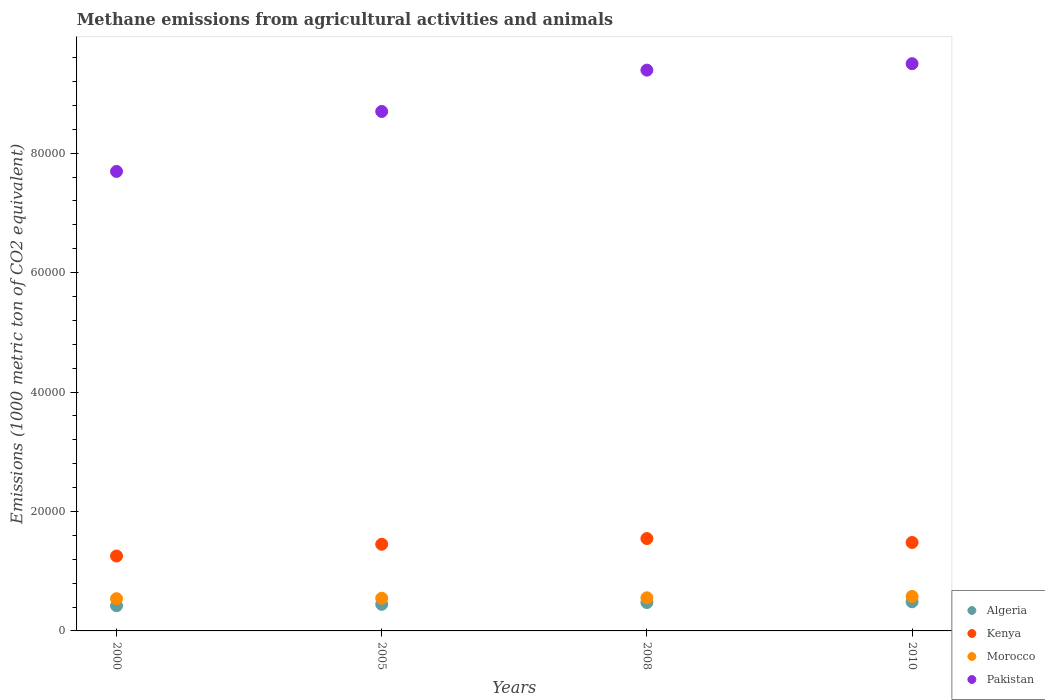How many different coloured dotlines are there?
Keep it short and to the point. 4. Is the number of dotlines equal to the number of legend labels?
Provide a short and direct response. Yes. What is the amount of methane emitted in Morocco in 2008?
Offer a very short reply. 5546.4. Across all years, what is the maximum amount of methane emitted in Algeria?
Your answer should be very brief. 4872.2. Across all years, what is the minimum amount of methane emitted in Kenya?
Keep it short and to the point. 1.25e+04. In which year was the amount of methane emitted in Algeria maximum?
Make the answer very short. 2010. In which year was the amount of methane emitted in Morocco minimum?
Your response must be concise. 2000. What is the total amount of methane emitted in Kenya in the graph?
Make the answer very short. 5.73e+04. What is the difference between the amount of methane emitted in Pakistan in 2000 and that in 2008?
Make the answer very short. -1.70e+04. What is the difference between the amount of methane emitted in Algeria in 2005 and the amount of methane emitted in Morocco in 2010?
Your answer should be very brief. -1327. What is the average amount of methane emitted in Pakistan per year?
Keep it short and to the point. 8.82e+04. In the year 2008, what is the difference between the amount of methane emitted in Kenya and amount of methane emitted in Pakistan?
Ensure brevity in your answer.  -7.84e+04. What is the ratio of the amount of methane emitted in Kenya in 2000 to that in 2010?
Offer a very short reply. 0.85. Is the amount of methane emitted in Algeria in 2000 less than that in 2010?
Keep it short and to the point. Yes. Is the difference between the amount of methane emitted in Kenya in 2000 and 2005 greater than the difference between the amount of methane emitted in Pakistan in 2000 and 2005?
Keep it short and to the point. Yes. What is the difference between the highest and the second highest amount of methane emitted in Morocco?
Provide a short and direct response. 232.7. What is the difference between the highest and the lowest amount of methane emitted in Kenya?
Your answer should be compact. 2922.2. Is it the case that in every year, the sum of the amount of methane emitted in Morocco and amount of methane emitted in Algeria  is greater than the amount of methane emitted in Pakistan?
Provide a short and direct response. No. Is the amount of methane emitted in Morocco strictly greater than the amount of methane emitted in Pakistan over the years?
Make the answer very short. No. How many years are there in the graph?
Ensure brevity in your answer.  4. What is the difference between two consecutive major ticks on the Y-axis?
Your answer should be very brief. 2.00e+04. Does the graph contain any zero values?
Your response must be concise. No. Does the graph contain grids?
Offer a terse response. No. Where does the legend appear in the graph?
Offer a very short reply. Bottom right. What is the title of the graph?
Make the answer very short. Methane emissions from agricultural activities and animals. Does "Guatemala" appear as one of the legend labels in the graph?
Keep it short and to the point. No. What is the label or title of the X-axis?
Your response must be concise. Years. What is the label or title of the Y-axis?
Offer a very short reply. Emissions (1000 metric ton of CO2 equivalent). What is the Emissions (1000 metric ton of CO2 equivalent) of Algeria in 2000?
Give a very brief answer. 4216.3. What is the Emissions (1000 metric ton of CO2 equivalent) of Kenya in 2000?
Offer a terse response. 1.25e+04. What is the Emissions (1000 metric ton of CO2 equivalent) in Morocco in 2000?
Keep it short and to the point. 5400.3. What is the Emissions (1000 metric ton of CO2 equivalent) in Pakistan in 2000?
Offer a terse response. 7.69e+04. What is the Emissions (1000 metric ton of CO2 equivalent) of Algeria in 2005?
Keep it short and to the point. 4452.1. What is the Emissions (1000 metric ton of CO2 equivalent) of Kenya in 2005?
Ensure brevity in your answer.  1.45e+04. What is the Emissions (1000 metric ton of CO2 equivalent) of Morocco in 2005?
Keep it short and to the point. 5471.4. What is the Emissions (1000 metric ton of CO2 equivalent) of Pakistan in 2005?
Your response must be concise. 8.70e+04. What is the Emissions (1000 metric ton of CO2 equivalent) of Algeria in 2008?
Provide a short and direct response. 4754.7. What is the Emissions (1000 metric ton of CO2 equivalent) in Kenya in 2008?
Your response must be concise. 1.55e+04. What is the Emissions (1000 metric ton of CO2 equivalent) in Morocco in 2008?
Make the answer very short. 5546.4. What is the Emissions (1000 metric ton of CO2 equivalent) in Pakistan in 2008?
Offer a terse response. 9.39e+04. What is the Emissions (1000 metric ton of CO2 equivalent) in Algeria in 2010?
Your answer should be compact. 4872.2. What is the Emissions (1000 metric ton of CO2 equivalent) in Kenya in 2010?
Give a very brief answer. 1.48e+04. What is the Emissions (1000 metric ton of CO2 equivalent) of Morocco in 2010?
Provide a short and direct response. 5779.1. What is the Emissions (1000 metric ton of CO2 equivalent) in Pakistan in 2010?
Provide a succinct answer. 9.50e+04. Across all years, what is the maximum Emissions (1000 metric ton of CO2 equivalent) in Algeria?
Offer a very short reply. 4872.2. Across all years, what is the maximum Emissions (1000 metric ton of CO2 equivalent) of Kenya?
Offer a very short reply. 1.55e+04. Across all years, what is the maximum Emissions (1000 metric ton of CO2 equivalent) of Morocco?
Offer a terse response. 5779.1. Across all years, what is the maximum Emissions (1000 metric ton of CO2 equivalent) in Pakistan?
Keep it short and to the point. 9.50e+04. Across all years, what is the minimum Emissions (1000 metric ton of CO2 equivalent) in Algeria?
Provide a succinct answer. 4216.3. Across all years, what is the minimum Emissions (1000 metric ton of CO2 equivalent) of Kenya?
Keep it short and to the point. 1.25e+04. Across all years, what is the minimum Emissions (1000 metric ton of CO2 equivalent) in Morocco?
Keep it short and to the point. 5400.3. Across all years, what is the minimum Emissions (1000 metric ton of CO2 equivalent) of Pakistan?
Your answer should be compact. 7.69e+04. What is the total Emissions (1000 metric ton of CO2 equivalent) in Algeria in the graph?
Ensure brevity in your answer.  1.83e+04. What is the total Emissions (1000 metric ton of CO2 equivalent) of Kenya in the graph?
Keep it short and to the point. 5.73e+04. What is the total Emissions (1000 metric ton of CO2 equivalent) in Morocco in the graph?
Your answer should be compact. 2.22e+04. What is the total Emissions (1000 metric ton of CO2 equivalent) in Pakistan in the graph?
Give a very brief answer. 3.53e+05. What is the difference between the Emissions (1000 metric ton of CO2 equivalent) of Algeria in 2000 and that in 2005?
Your answer should be compact. -235.8. What is the difference between the Emissions (1000 metric ton of CO2 equivalent) of Kenya in 2000 and that in 2005?
Your answer should be very brief. -1969.1. What is the difference between the Emissions (1000 metric ton of CO2 equivalent) of Morocco in 2000 and that in 2005?
Your response must be concise. -71.1. What is the difference between the Emissions (1000 metric ton of CO2 equivalent) in Pakistan in 2000 and that in 2005?
Your response must be concise. -1.00e+04. What is the difference between the Emissions (1000 metric ton of CO2 equivalent) of Algeria in 2000 and that in 2008?
Make the answer very short. -538.4. What is the difference between the Emissions (1000 metric ton of CO2 equivalent) in Kenya in 2000 and that in 2008?
Provide a short and direct response. -2922.2. What is the difference between the Emissions (1000 metric ton of CO2 equivalent) of Morocco in 2000 and that in 2008?
Your answer should be very brief. -146.1. What is the difference between the Emissions (1000 metric ton of CO2 equivalent) in Pakistan in 2000 and that in 2008?
Ensure brevity in your answer.  -1.70e+04. What is the difference between the Emissions (1000 metric ton of CO2 equivalent) of Algeria in 2000 and that in 2010?
Ensure brevity in your answer.  -655.9. What is the difference between the Emissions (1000 metric ton of CO2 equivalent) in Kenya in 2000 and that in 2010?
Your answer should be very brief. -2265.8. What is the difference between the Emissions (1000 metric ton of CO2 equivalent) in Morocco in 2000 and that in 2010?
Keep it short and to the point. -378.8. What is the difference between the Emissions (1000 metric ton of CO2 equivalent) in Pakistan in 2000 and that in 2010?
Give a very brief answer. -1.80e+04. What is the difference between the Emissions (1000 metric ton of CO2 equivalent) of Algeria in 2005 and that in 2008?
Give a very brief answer. -302.6. What is the difference between the Emissions (1000 metric ton of CO2 equivalent) in Kenya in 2005 and that in 2008?
Offer a very short reply. -953.1. What is the difference between the Emissions (1000 metric ton of CO2 equivalent) in Morocco in 2005 and that in 2008?
Provide a succinct answer. -75. What is the difference between the Emissions (1000 metric ton of CO2 equivalent) in Pakistan in 2005 and that in 2008?
Keep it short and to the point. -6920.4. What is the difference between the Emissions (1000 metric ton of CO2 equivalent) in Algeria in 2005 and that in 2010?
Make the answer very short. -420.1. What is the difference between the Emissions (1000 metric ton of CO2 equivalent) of Kenya in 2005 and that in 2010?
Your answer should be compact. -296.7. What is the difference between the Emissions (1000 metric ton of CO2 equivalent) in Morocco in 2005 and that in 2010?
Ensure brevity in your answer.  -307.7. What is the difference between the Emissions (1000 metric ton of CO2 equivalent) in Pakistan in 2005 and that in 2010?
Your response must be concise. -8002.4. What is the difference between the Emissions (1000 metric ton of CO2 equivalent) in Algeria in 2008 and that in 2010?
Make the answer very short. -117.5. What is the difference between the Emissions (1000 metric ton of CO2 equivalent) of Kenya in 2008 and that in 2010?
Offer a very short reply. 656.4. What is the difference between the Emissions (1000 metric ton of CO2 equivalent) of Morocco in 2008 and that in 2010?
Your answer should be compact. -232.7. What is the difference between the Emissions (1000 metric ton of CO2 equivalent) in Pakistan in 2008 and that in 2010?
Your answer should be very brief. -1082. What is the difference between the Emissions (1000 metric ton of CO2 equivalent) of Algeria in 2000 and the Emissions (1000 metric ton of CO2 equivalent) of Kenya in 2005?
Ensure brevity in your answer.  -1.03e+04. What is the difference between the Emissions (1000 metric ton of CO2 equivalent) in Algeria in 2000 and the Emissions (1000 metric ton of CO2 equivalent) in Morocco in 2005?
Your response must be concise. -1255.1. What is the difference between the Emissions (1000 metric ton of CO2 equivalent) in Algeria in 2000 and the Emissions (1000 metric ton of CO2 equivalent) in Pakistan in 2005?
Your response must be concise. -8.28e+04. What is the difference between the Emissions (1000 metric ton of CO2 equivalent) of Kenya in 2000 and the Emissions (1000 metric ton of CO2 equivalent) of Morocco in 2005?
Give a very brief answer. 7072.2. What is the difference between the Emissions (1000 metric ton of CO2 equivalent) in Kenya in 2000 and the Emissions (1000 metric ton of CO2 equivalent) in Pakistan in 2005?
Give a very brief answer. -7.44e+04. What is the difference between the Emissions (1000 metric ton of CO2 equivalent) of Morocco in 2000 and the Emissions (1000 metric ton of CO2 equivalent) of Pakistan in 2005?
Ensure brevity in your answer.  -8.16e+04. What is the difference between the Emissions (1000 metric ton of CO2 equivalent) of Algeria in 2000 and the Emissions (1000 metric ton of CO2 equivalent) of Kenya in 2008?
Keep it short and to the point. -1.12e+04. What is the difference between the Emissions (1000 metric ton of CO2 equivalent) of Algeria in 2000 and the Emissions (1000 metric ton of CO2 equivalent) of Morocco in 2008?
Provide a short and direct response. -1330.1. What is the difference between the Emissions (1000 metric ton of CO2 equivalent) of Algeria in 2000 and the Emissions (1000 metric ton of CO2 equivalent) of Pakistan in 2008?
Your answer should be very brief. -8.97e+04. What is the difference between the Emissions (1000 metric ton of CO2 equivalent) of Kenya in 2000 and the Emissions (1000 metric ton of CO2 equivalent) of Morocco in 2008?
Your answer should be compact. 6997.2. What is the difference between the Emissions (1000 metric ton of CO2 equivalent) in Kenya in 2000 and the Emissions (1000 metric ton of CO2 equivalent) in Pakistan in 2008?
Your response must be concise. -8.14e+04. What is the difference between the Emissions (1000 metric ton of CO2 equivalent) of Morocco in 2000 and the Emissions (1000 metric ton of CO2 equivalent) of Pakistan in 2008?
Your answer should be compact. -8.85e+04. What is the difference between the Emissions (1000 metric ton of CO2 equivalent) of Algeria in 2000 and the Emissions (1000 metric ton of CO2 equivalent) of Kenya in 2010?
Your response must be concise. -1.06e+04. What is the difference between the Emissions (1000 metric ton of CO2 equivalent) of Algeria in 2000 and the Emissions (1000 metric ton of CO2 equivalent) of Morocco in 2010?
Provide a succinct answer. -1562.8. What is the difference between the Emissions (1000 metric ton of CO2 equivalent) in Algeria in 2000 and the Emissions (1000 metric ton of CO2 equivalent) in Pakistan in 2010?
Your answer should be very brief. -9.08e+04. What is the difference between the Emissions (1000 metric ton of CO2 equivalent) of Kenya in 2000 and the Emissions (1000 metric ton of CO2 equivalent) of Morocco in 2010?
Ensure brevity in your answer.  6764.5. What is the difference between the Emissions (1000 metric ton of CO2 equivalent) of Kenya in 2000 and the Emissions (1000 metric ton of CO2 equivalent) of Pakistan in 2010?
Offer a terse response. -8.24e+04. What is the difference between the Emissions (1000 metric ton of CO2 equivalent) in Morocco in 2000 and the Emissions (1000 metric ton of CO2 equivalent) in Pakistan in 2010?
Provide a short and direct response. -8.96e+04. What is the difference between the Emissions (1000 metric ton of CO2 equivalent) of Algeria in 2005 and the Emissions (1000 metric ton of CO2 equivalent) of Kenya in 2008?
Provide a short and direct response. -1.10e+04. What is the difference between the Emissions (1000 metric ton of CO2 equivalent) of Algeria in 2005 and the Emissions (1000 metric ton of CO2 equivalent) of Morocco in 2008?
Offer a terse response. -1094.3. What is the difference between the Emissions (1000 metric ton of CO2 equivalent) of Algeria in 2005 and the Emissions (1000 metric ton of CO2 equivalent) of Pakistan in 2008?
Provide a succinct answer. -8.95e+04. What is the difference between the Emissions (1000 metric ton of CO2 equivalent) of Kenya in 2005 and the Emissions (1000 metric ton of CO2 equivalent) of Morocco in 2008?
Provide a succinct answer. 8966.3. What is the difference between the Emissions (1000 metric ton of CO2 equivalent) in Kenya in 2005 and the Emissions (1000 metric ton of CO2 equivalent) in Pakistan in 2008?
Give a very brief answer. -7.94e+04. What is the difference between the Emissions (1000 metric ton of CO2 equivalent) of Morocco in 2005 and the Emissions (1000 metric ton of CO2 equivalent) of Pakistan in 2008?
Your response must be concise. -8.84e+04. What is the difference between the Emissions (1000 metric ton of CO2 equivalent) of Algeria in 2005 and the Emissions (1000 metric ton of CO2 equivalent) of Kenya in 2010?
Ensure brevity in your answer.  -1.04e+04. What is the difference between the Emissions (1000 metric ton of CO2 equivalent) of Algeria in 2005 and the Emissions (1000 metric ton of CO2 equivalent) of Morocco in 2010?
Your answer should be very brief. -1327. What is the difference between the Emissions (1000 metric ton of CO2 equivalent) of Algeria in 2005 and the Emissions (1000 metric ton of CO2 equivalent) of Pakistan in 2010?
Offer a terse response. -9.05e+04. What is the difference between the Emissions (1000 metric ton of CO2 equivalent) in Kenya in 2005 and the Emissions (1000 metric ton of CO2 equivalent) in Morocco in 2010?
Your answer should be very brief. 8733.6. What is the difference between the Emissions (1000 metric ton of CO2 equivalent) in Kenya in 2005 and the Emissions (1000 metric ton of CO2 equivalent) in Pakistan in 2010?
Make the answer very short. -8.05e+04. What is the difference between the Emissions (1000 metric ton of CO2 equivalent) of Morocco in 2005 and the Emissions (1000 metric ton of CO2 equivalent) of Pakistan in 2010?
Offer a terse response. -8.95e+04. What is the difference between the Emissions (1000 metric ton of CO2 equivalent) in Algeria in 2008 and the Emissions (1000 metric ton of CO2 equivalent) in Kenya in 2010?
Keep it short and to the point. -1.01e+04. What is the difference between the Emissions (1000 metric ton of CO2 equivalent) of Algeria in 2008 and the Emissions (1000 metric ton of CO2 equivalent) of Morocco in 2010?
Your answer should be compact. -1024.4. What is the difference between the Emissions (1000 metric ton of CO2 equivalent) of Algeria in 2008 and the Emissions (1000 metric ton of CO2 equivalent) of Pakistan in 2010?
Offer a terse response. -9.02e+04. What is the difference between the Emissions (1000 metric ton of CO2 equivalent) in Kenya in 2008 and the Emissions (1000 metric ton of CO2 equivalent) in Morocco in 2010?
Your response must be concise. 9686.7. What is the difference between the Emissions (1000 metric ton of CO2 equivalent) of Kenya in 2008 and the Emissions (1000 metric ton of CO2 equivalent) of Pakistan in 2010?
Your answer should be compact. -7.95e+04. What is the difference between the Emissions (1000 metric ton of CO2 equivalent) of Morocco in 2008 and the Emissions (1000 metric ton of CO2 equivalent) of Pakistan in 2010?
Offer a very short reply. -8.94e+04. What is the average Emissions (1000 metric ton of CO2 equivalent) of Algeria per year?
Provide a short and direct response. 4573.82. What is the average Emissions (1000 metric ton of CO2 equivalent) in Kenya per year?
Your answer should be very brief. 1.43e+04. What is the average Emissions (1000 metric ton of CO2 equivalent) of Morocco per year?
Give a very brief answer. 5549.3. What is the average Emissions (1000 metric ton of CO2 equivalent) in Pakistan per year?
Your answer should be very brief. 8.82e+04. In the year 2000, what is the difference between the Emissions (1000 metric ton of CO2 equivalent) of Algeria and Emissions (1000 metric ton of CO2 equivalent) of Kenya?
Ensure brevity in your answer.  -8327.3. In the year 2000, what is the difference between the Emissions (1000 metric ton of CO2 equivalent) of Algeria and Emissions (1000 metric ton of CO2 equivalent) of Morocco?
Keep it short and to the point. -1184. In the year 2000, what is the difference between the Emissions (1000 metric ton of CO2 equivalent) of Algeria and Emissions (1000 metric ton of CO2 equivalent) of Pakistan?
Keep it short and to the point. -7.27e+04. In the year 2000, what is the difference between the Emissions (1000 metric ton of CO2 equivalent) of Kenya and Emissions (1000 metric ton of CO2 equivalent) of Morocco?
Provide a succinct answer. 7143.3. In the year 2000, what is the difference between the Emissions (1000 metric ton of CO2 equivalent) of Kenya and Emissions (1000 metric ton of CO2 equivalent) of Pakistan?
Give a very brief answer. -6.44e+04. In the year 2000, what is the difference between the Emissions (1000 metric ton of CO2 equivalent) in Morocco and Emissions (1000 metric ton of CO2 equivalent) in Pakistan?
Provide a succinct answer. -7.15e+04. In the year 2005, what is the difference between the Emissions (1000 metric ton of CO2 equivalent) of Algeria and Emissions (1000 metric ton of CO2 equivalent) of Kenya?
Keep it short and to the point. -1.01e+04. In the year 2005, what is the difference between the Emissions (1000 metric ton of CO2 equivalent) in Algeria and Emissions (1000 metric ton of CO2 equivalent) in Morocco?
Your answer should be very brief. -1019.3. In the year 2005, what is the difference between the Emissions (1000 metric ton of CO2 equivalent) in Algeria and Emissions (1000 metric ton of CO2 equivalent) in Pakistan?
Ensure brevity in your answer.  -8.25e+04. In the year 2005, what is the difference between the Emissions (1000 metric ton of CO2 equivalent) in Kenya and Emissions (1000 metric ton of CO2 equivalent) in Morocco?
Provide a short and direct response. 9041.3. In the year 2005, what is the difference between the Emissions (1000 metric ton of CO2 equivalent) in Kenya and Emissions (1000 metric ton of CO2 equivalent) in Pakistan?
Your response must be concise. -7.25e+04. In the year 2005, what is the difference between the Emissions (1000 metric ton of CO2 equivalent) of Morocco and Emissions (1000 metric ton of CO2 equivalent) of Pakistan?
Provide a short and direct response. -8.15e+04. In the year 2008, what is the difference between the Emissions (1000 metric ton of CO2 equivalent) in Algeria and Emissions (1000 metric ton of CO2 equivalent) in Kenya?
Offer a terse response. -1.07e+04. In the year 2008, what is the difference between the Emissions (1000 metric ton of CO2 equivalent) in Algeria and Emissions (1000 metric ton of CO2 equivalent) in Morocco?
Provide a short and direct response. -791.7. In the year 2008, what is the difference between the Emissions (1000 metric ton of CO2 equivalent) of Algeria and Emissions (1000 metric ton of CO2 equivalent) of Pakistan?
Offer a very short reply. -8.92e+04. In the year 2008, what is the difference between the Emissions (1000 metric ton of CO2 equivalent) in Kenya and Emissions (1000 metric ton of CO2 equivalent) in Morocco?
Your answer should be compact. 9919.4. In the year 2008, what is the difference between the Emissions (1000 metric ton of CO2 equivalent) of Kenya and Emissions (1000 metric ton of CO2 equivalent) of Pakistan?
Keep it short and to the point. -7.84e+04. In the year 2008, what is the difference between the Emissions (1000 metric ton of CO2 equivalent) of Morocco and Emissions (1000 metric ton of CO2 equivalent) of Pakistan?
Provide a short and direct response. -8.84e+04. In the year 2010, what is the difference between the Emissions (1000 metric ton of CO2 equivalent) in Algeria and Emissions (1000 metric ton of CO2 equivalent) in Kenya?
Provide a succinct answer. -9937.2. In the year 2010, what is the difference between the Emissions (1000 metric ton of CO2 equivalent) of Algeria and Emissions (1000 metric ton of CO2 equivalent) of Morocco?
Provide a short and direct response. -906.9. In the year 2010, what is the difference between the Emissions (1000 metric ton of CO2 equivalent) in Algeria and Emissions (1000 metric ton of CO2 equivalent) in Pakistan?
Provide a succinct answer. -9.01e+04. In the year 2010, what is the difference between the Emissions (1000 metric ton of CO2 equivalent) in Kenya and Emissions (1000 metric ton of CO2 equivalent) in Morocco?
Keep it short and to the point. 9030.3. In the year 2010, what is the difference between the Emissions (1000 metric ton of CO2 equivalent) of Kenya and Emissions (1000 metric ton of CO2 equivalent) of Pakistan?
Offer a very short reply. -8.02e+04. In the year 2010, what is the difference between the Emissions (1000 metric ton of CO2 equivalent) in Morocco and Emissions (1000 metric ton of CO2 equivalent) in Pakistan?
Your answer should be compact. -8.92e+04. What is the ratio of the Emissions (1000 metric ton of CO2 equivalent) of Algeria in 2000 to that in 2005?
Your answer should be very brief. 0.95. What is the ratio of the Emissions (1000 metric ton of CO2 equivalent) in Kenya in 2000 to that in 2005?
Ensure brevity in your answer.  0.86. What is the ratio of the Emissions (1000 metric ton of CO2 equivalent) in Pakistan in 2000 to that in 2005?
Make the answer very short. 0.88. What is the ratio of the Emissions (1000 metric ton of CO2 equivalent) of Algeria in 2000 to that in 2008?
Make the answer very short. 0.89. What is the ratio of the Emissions (1000 metric ton of CO2 equivalent) in Kenya in 2000 to that in 2008?
Your response must be concise. 0.81. What is the ratio of the Emissions (1000 metric ton of CO2 equivalent) in Morocco in 2000 to that in 2008?
Provide a succinct answer. 0.97. What is the ratio of the Emissions (1000 metric ton of CO2 equivalent) in Pakistan in 2000 to that in 2008?
Your answer should be compact. 0.82. What is the ratio of the Emissions (1000 metric ton of CO2 equivalent) in Algeria in 2000 to that in 2010?
Offer a very short reply. 0.87. What is the ratio of the Emissions (1000 metric ton of CO2 equivalent) of Kenya in 2000 to that in 2010?
Provide a succinct answer. 0.85. What is the ratio of the Emissions (1000 metric ton of CO2 equivalent) in Morocco in 2000 to that in 2010?
Ensure brevity in your answer.  0.93. What is the ratio of the Emissions (1000 metric ton of CO2 equivalent) of Pakistan in 2000 to that in 2010?
Provide a short and direct response. 0.81. What is the ratio of the Emissions (1000 metric ton of CO2 equivalent) in Algeria in 2005 to that in 2008?
Give a very brief answer. 0.94. What is the ratio of the Emissions (1000 metric ton of CO2 equivalent) of Kenya in 2005 to that in 2008?
Provide a short and direct response. 0.94. What is the ratio of the Emissions (1000 metric ton of CO2 equivalent) in Morocco in 2005 to that in 2008?
Provide a succinct answer. 0.99. What is the ratio of the Emissions (1000 metric ton of CO2 equivalent) in Pakistan in 2005 to that in 2008?
Offer a very short reply. 0.93. What is the ratio of the Emissions (1000 metric ton of CO2 equivalent) of Algeria in 2005 to that in 2010?
Provide a succinct answer. 0.91. What is the ratio of the Emissions (1000 metric ton of CO2 equivalent) in Kenya in 2005 to that in 2010?
Your answer should be compact. 0.98. What is the ratio of the Emissions (1000 metric ton of CO2 equivalent) of Morocco in 2005 to that in 2010?
Your answer should be very brief. 0.95. What is the ratio of the Emissions (1000 metric ton of CO2 equivalent) of Pakistan in 2005 to that in 2010?
Offer a very short reply. 0.92. What is the ratio of the Emissions (1000 metric ton of CO2 equivalent) in Algeria in 2008 to that in 2010?
Provide a short and direct response. 0.98. What is the ratio of the Emissions (1000 metric ton of CO2 equivalent) in Kenya in 2008 to that in 2010?
Give a very brief answer. 1.04. What is the ratio of the Emissions (1000 metric ton of CO2 equivalent) in Morocco in 2008 to that in 2010?
Ensure brevity in your answer.  0.96. What is the ratio of the Emissions (1000 metric ton of CO2 equivalent) in Pakistan in 2008 to that in 2010?
Give a very brief answer. 0.99. What is the difference between the highest and the second highest Emissions (1000 metric ton of CO2 equivalent) of Algeria?
Your answer should be very brief. 117.5. What is the difference between the highest and the second highest Emissions (1000 metric ton of CO2 equivalent) in Kenya?
Ensure brevity in your answer.  656.4. What is the difference between the highest and the second highest Emissions (1000 metric ton of CO2 equivalent) in Morocco?
Keep it short and to the point. 232.7. What is the difference between the highest and the second highest Emissions (1000 metric ton of CO2 equivalent) of Pakistan?
Offer a very short reply. 1082. What is the difference between the highest and the lowest Emissions (1000 metric ton of CO2 equivalent) of Algeria?
Your response must be concise. 655.9. What is the difference between the highest and the lowest Emissions (1000 metric ton of CO2 equivalent) in Kenya?
Offer a very short reply. 2922.2. What is the difference between the highest and the lowest Emissions (1000 metric ton of CO2 equivalent) of Morocco?
Your response must be concise. 378.8. What is the difference between the highest and the lowest Emissions (1000 metric ton of CO2 equivalent) in Pakistan?
Offer a very short reply. 1.80e+04. 